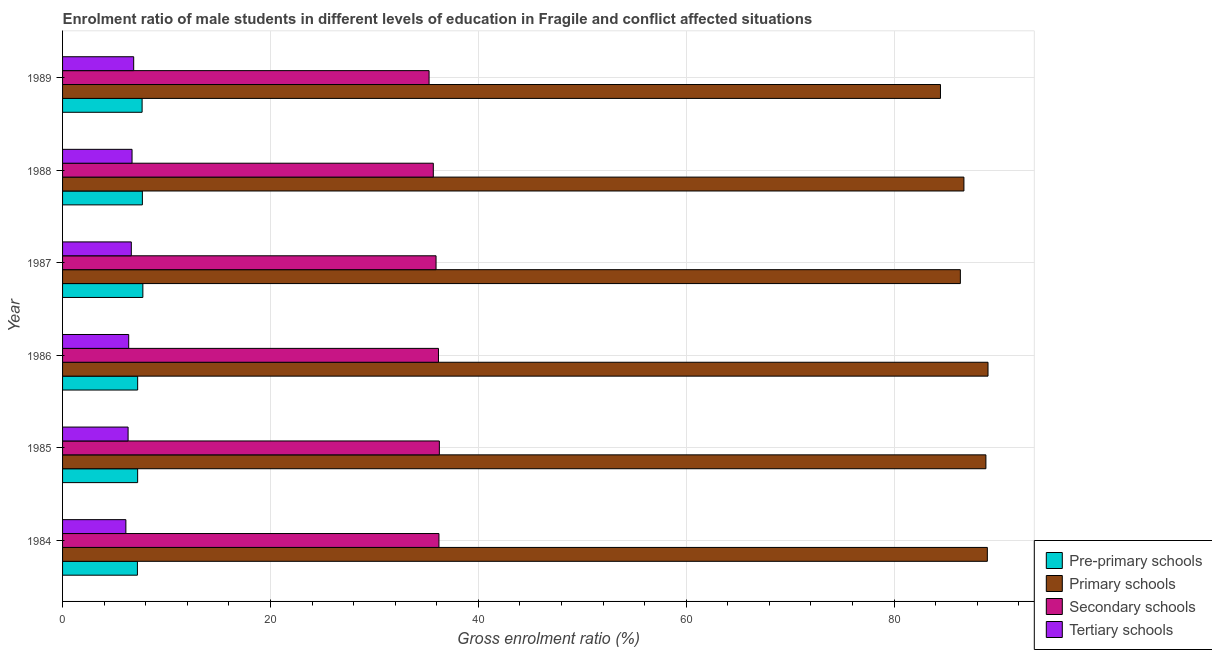How many groups of bars are there?
Offer a very short reply. 6. Are the number of bars on each tick of the Y-axis equal?
Your answer should be compact. Yes. How many bars are there on the 2nd tick from the top?
Ensure brevity in your answer.  4. What is the label of the 6th group of bars from the top?
Keep it short and to the point. 1984. What is the gross enrolment ratio(female) in tertiary schools in 1989?
Offer a terse response. 6.84. Across all years, what is the maximum gross enrolment ratio(female) in pre-primary schools?
Your response must be concise. 7.73. Across all years, what is the minimum gross enrolment ratio(female) in pre-primary schools?
Your answer should be compact. 7.2. In which year was the gross enrolment ratio(female) in tertiary schools maximum?
Offer a very short reply. 1989. What is the total gross enrolment ratio(female) in primary schools in the graph?
Make the answer very short. 524.46. What is the difference between the gross enrolment ratio(female) in tertiary schools in 1986 and that in 1988?
Your answer should be very brief. -0.32. What is the difference between the gross enrolment ratio(female) in tertiary schools in 1988 and the gross enrolment ratio(female) in secondary schools in 1987?
Give a very brief answer. -29.25. What is the average gross enrolment ratio(female) in pre-primary schools per year?
Provide a short and direct response. 7.45. In the year 1986, what is the difference between the gross enrolment ratio(female) in primary schools and gross enrolment ratio(female) in pre-primary schools?
Offer a very short reply. 81.82. In how many years, is the gross enrolment ratio(female) in tertiary schools greater than 88 %?
Offer a very short reply. 0. What is the difference between the highest and the second highest gross enrolment ratio(female) in secondary schools?
Your response must be concise. 0.04. What is the difference between the highest and the lowest gross enrolment ratio(female) in primary schools?
Your answer should be very brief. 4.57. In how many years, is the gross enrolment ratio(female) in tertiary schools greater than the average gross enrolment ratio(female) in tertiary schools taken over all years?
Provide a succinct answer. 3. What does the 2nd bar from the top in 1984 represents?
Keep it short and to the point. Secondary schools. What does the 3rd bar from the bottom in 1984 represents?
Your response must be concise. Secondary schools. How many bars are there?
Ensure brevity in your answer.  24. Are all the bars in the graph horizontal?
Keep it short and to the point. Yes. What is the difference between two consecutive major ticks on the X-axis?
Your answer should be very brief. 20. Does the graph contain grids?
Provide a succinct answer. Yes. How many legend labels are there?
Provide a short and direct response. 4. How are the legend labels stacked?
Keep it short and to the point. Vertical. What is the title of the graph?
Provide a succinct answer. Enrolment ratio of male students in different levels of education in Fragile and conflict affected situations. Does "Quality of logistic services" appear as one of the legend labels in the graph?
Provide a short and direct response. No. What is the label or title of the X-axis?
Provide a short and direct response. Gross enrolment ratio (%). What is the Gross enrolment ratio (%) of Pre-primary schools in 1984?
Your response must be concise. 7.2. What is the Gross enrolment ratio (%) of Primary schools in 1984?
Your response must be concise. 88.98. What is the Gross enrolment ratio (%) of Secondary schools in 1984?
Keep it short and to the point. 36.22. What is the Gross enrolment ratio (%) in Tertiary schools in 1984?
Give a very brief answer. 6.09. What is the Gross enrolment ratio (%) in Pre-primary schools in 1985?
Offer a terse response. 7.22. What is the Gross enrolment ratio (%) in Primary schools in 1985?
Your answer should be very brief. 88.84. What is the Gross enrolment ratio (%) of Secondary schools in 1985?
Offer a terse response. 36.26. What is the Gross enrolment ratio (%) of Tertiary schools in 1985?
Your answer should be very brief. 6.31. What is the Gross enrolment ratio (%) of Pre-primary schools in 1986?
Offer a very short reply. 7.23. What is the Gross enrolment ratio (%) of Primary schools in 1986?
Your answer should be compact. 89.05. What is the Gross enrolment ratio (%) in Secondary schools in 1986?
Your answer should be compact. 36.17. What is the Gross enrolment ratio (%) of Tertiary schools in 1986?
Make the answer very short. 6.36. What is the Gross enrolment ratio (%) in Pre-primary schools in 1987?
Provide a succinct answer. 7.73. What is the Gross enrolment ratio (%) of Primary schools in 1987?
Your answer should be compact. 86.39. What is the Gross enrolment ratio (%) in Secondary schools in 1987?
Keep it short and to the point. 35.94. What is the Gross enrolment ratio (%) in Tertiary schools in 1987?
Give a very brief answer. 6.61. What is the Gross enrolment ratio (%) in Pre-primary schools in 1988?
Provide a short and direct response. 7.68. What is the Gross enrolment ratio (%) in Primary schools in 1988?
Ensure brevity in your answer.  86.73. What is the Gross enrolment ratio (%) of Secondary schools in 1988?
Make the answer very short. 35.67. What is the Gross enrolment ratio (%) of Tertiary schools in 1988?
Your response must be concise. 6.69. What is the Gross enrolment ratio (%) in Pre-primary schools in 1989?
Ensure brevity in your answer.  7.65. What is the Gross enrolment ratio (%) in Primary schools in 1989?
Keep it short and to the point. 84.47. What is the Gross enrolment ratio (%) in Secondary schools in 1989?
Offer a very short reply. 35.27. What is the Gross enrolment ratio (%) of Tertiary schools in 1989?
Your response must be concise. 6.84. Across all years, what is the maximum Gross enrolment ratio (%) in Pre-primary schools?
Provide a short and direct response. 7.73. Across all years, what is the maximum Gross enrolment ratio (%) of Primary schools?
Give a very brief answer. 89.05. Across all years, what is the maximum Gross enrolment ratio (%) in Secondary schools?
Keep it short and to the point. 36.26. Across all years, what is the maximum Gross enrolment ratio (%) in Tertiary schools?
Your answer should be compact. 6.84. Across all years, what is the minimum Gross enrolment ratio (%) in Pre-primary schools?
Provide a succinct answer. 7.2. Across all years, what is the minimum Gross enrolment ratio (%) in Primary schools?
Give a very brief answer. 84.47. Across all years, what is the minimum Gross enrolment ratio (%) of Secondary schools?
Your answer should be compact. 35.27. Across all years, what is the minimum Gross enrolment ratio (%) in Tertiary schools?
Give a very brief answer. 6.09. What is the total Gross enrolment ratio (%) in Pre-primary schools in the graph?
Offer a very short reply. 44.71. What is the total Gross enrolment ratio (%) of Primary schools in the graph?
Ensure brevity in your answer.  524.46. What is the total Gross enrolment ratio (%) of Secondary schools in the graph?
Keep it short and to the point. 215.52. What is the total Gross enrolment ratio (%) in Tertiary schools in the graph?
Your response must be concise. 38.9. What is the difference between the Gross enrolment ratio (%) in Pre-primary schools in 1984 and that in 1985?
Keep it short and to the point. -0.02. What is the difference between the Gross enrolment ratio (%) in Primary schools in 1984 and that in 1985?
Keep it short and to the point. 0.14. What is the difference between the Gross enrolment ratio (%) of Secondary schools in 1984 and that in 1985?
Offer a very short reply. -0.04. What is the difference between the Gross enrolment ratio (%) of Tertiary schools in 1984 and that in 1985?
Provide a short and direct response. -0.21. What is the difference between the Gross enrolment ratio (%) of Pre-primary schools in 1984 and that in 1986?
Provide a short and direct response. -0.02. What is the difference between the Gross enrolment ratio (%) of Primary schools in 1984 and that in 1986?
Ensure brevity in your answer.  -0.06. What is the difference between the Gross enrolment ratio (%) in Secondary schools in 1984 and that in 1986?
Provide a succinct answer. 0.05. What is the difference between the Gross enrolment ratio (%) of Tertiary schools in 1984 and that in 1986?
Provide a short and direct response. -0.27. What is the difference between the Gross enrolment ratio (%) in Pre-primary schools in 1984 and that in 1987?
Give a very brief answer. -0.52. What is the difference between the Gross enrolment ratio (%) in Primary schools in 1984 and that in 1987?
Make the answer very short. 2.6. What is the difference between the Gross enrolment ratio (%) of Secondary schools in 1984 and that in 1987?
Provide a short and direct response. 0.28. What is the difference between the Gross enrolment ratio (%) in Tertiary schools in 1984 and that in 1987?
Your answer should be very brief. -0.52. What is the difference between the Gross enrolment ratio (%) of Pre-primary schools in 1984 and that in 1988?
Give a very brief answer. -0.48. What is the difference between the Gross enrolment ratio (%) of Primary schools in 1984 and that in 1988?
Keep it short and to the point. 2.25. What is the difference between the Gross enrolment ratio (%) of Secondary schools in 1984 and that in 1988?
Offer a very short reply. 0.54. What is the difference between the Gross enrolment ratio (%) of Tertiary schools in 1984 and that in 1988?
Provide a succinct answer. -0.59. What is the difference between the Gross enrolment ratio (%) of Pre-primary schools in 1984 and that in 1989?
Your answer should be compact. -0.45. What is the difference between the Gross enrolment ratio (%) of Primary schools in 1984 and that in 1989?
Your response must be concise. 4.51. What is the difference between the Gross enrolment ratio (%) in Secondary schools in 1984 and that in 1989?
Your answer should be compact. 0.95. What is the difference between the Gross enrolment ratio (%) of Tertiary schools in 1984 and that in 1989?
Ensure brevity in your answer.  -0.75. What is the difference between the Gross enrolment ratio (%) in Pre-primary schools in 1985 and that in 1986?
Your response must be concise. -0. What is the difference between the Gross enrolment ratio (%) in Primary schools in 1985 and that in 1986?
Your answer should be very brief. -0.2. What is the difference between the Gross enrolment ratio (%) of Secondary schools in 1985 and that in 1986?
Ensure brevity in your answer.  0.09. What is the difference between the Gross enrolment ratio (%) of Tertiary schools in 1985 and that in 1986?
Offer a very short reply. -0.06. What is the difference between the Gross enrolment ratio (%) of Pre-primary schools in 1985 and that in 1987?
Ensure brevity in your answer.  -0.5. What is the difference between the Gross enrolment ratio (%) in Primary schools in 1985 and that in 1987?
Offer a terse response. 2.46. What is the difference between the Gross enrolment ratio (%) of Secondary schools in 1985 and that in 1987?
Ensure brevity in your answer.  0.32. What is the difference between the Gross enrolment ratio (%) in Tertiary schools in 1985 and that in 1987?
Provide a succinct answer. -0.31. What is the difference between the Gross enrolment ratio (%) in Pre-primary schools in 1985 and that in 1988?
Your response must be concise. -0.46. What is the difference between the Gross enrolment ratio (%) in Primary schools in 1985 and that in 1988?
Make the answer very short. 2.12. What is the difference between the Gross enrolment ratio (%) of Secondary schools in 1985 and that in 1988?
Ensure brevity in your answer.  0.58. What is the difference between the Gross enrolment ratio (%) of Tertiary schools in 1985 and that in 1988?
Make the answer very short. -0.38. What is the difference between the Gross enrolment ratio (%) in Pre-primary schools in 1985 and that in 1989?
Your response must be concise. -0.43. What is the difference between the Gross enrolment ratio (%) of Primary schools in 1985 and that in 1989?
Ensure brevity in your answer.  4.37. What is the difference between the Gross enrolment ratio (%) of Tertiary schools in 1985 and that in 1989?
Provide a succinct answer. -0.54. What is the difference between the Gross enrolment ratio (%) of Pre-primary schools in 1986 and that in 1987?
Make the answer very short. -0.5. What is the difference between the Gross enrolment ratio (%) in Primary schools in 1986 and that in 1987?
Your answer should be compact. 2.66. What is the difference between the Gross enrolment ratio (%) in Secondary schools in 1986 and that in 1987?
Ensure brevity in your answer.  0.23. What is the difference between the Gross enrolment ratio (%) in Tertiary schools in 1986 and that in 1987?
Keep it short and to the point. -0.25. What is the difference between the Gross enrolment ratio (%) of Pre-primary schools in 1986 and that in 1988?
Give a very brief answer. -0.45. What is the difference between the Gross enrolment ratio (%) in Primary schools in 1986 and that in 1988?
Offer a terse response. 2.32. What is the difference between the Gross enrolment ratio (%) of Secondary schools in 1986 and that in 1988?
Your answer should be very brief. 0.5. What is the difference between the Gross enrolment ratio (%) of Tertiary schools in 1986 and that in 1988?
Keep it short and to the point. -0.32. What is the difference between the Gross enrolment ratio (%) in Pre-primary schools in 1986 and that in 1989?
Your answer should be compact. -0.43. What is the difference between the Gross enrolment ratio (%) in Primary schools in 1986 and that in 1989?
Your answer should be compact. 4.57. What is the difference between the Gross enrolment ratio (%) of Secondary schools in 1986 and that in 1989?
Provide a short and direct response. 0.9. What is the difference between the Gross enrolment ratio (%) in Tertiary schools in 1986 and that in 1989?
Your answer should be very brief. -0.48. What is the difference between the Gross enrolment ratio (%) in Pre-primary schools in 1987 and that in 1988?
Provide a succinct answer. 0.05. What is the difference between the Gross enrolment ratio (%) in Primary schools in 1987 and that in 1988?
Keep it short and to the point. -0.34. What is the difference between the Gross enrolment ratio (%) of Secondary schools in 1987 and that in 1988?
Give a very brief answer. 0.26. What is the difference between the Gross enrolment ratio (%) in Tertiary schools in 1987 and that in 1988?
Offer a very short reply. -0.07. What is the difference between the Gross enrolment ratio (%) of Pre-primary schools in 1987 and that in 1989?
Your answer should be very brief. 0.07. What is the difference between the Gross enrolment ratio (%) in Primary schools in 1987 and that in 1989?
Your answer should be very brief. 1.91. What is the difference between the Gross enrolment ratio (%) of Secondary schools in 1987 and that in 1989?
Give a very brief answer. 0.67. What is the difference between the Gross enrolment ratio (%) of Tertiary schools in 1987 and that in 1989?
Give a very brief answer. -0.23. What is the difference between the Gross enrolment ratio (%) of Pre-primary schools in 1988 and that in 1989?
Offer a very short reply. 0.03. What is the difference between the Gross enrolment ratio (%) of Primary schools in 1988 and that in 1989?
Provide a succinct answer. 2.26. What is the difference between the Gross enrolment ratio (%) in Secondary schools in 1988 and that in 1989?
Provide a short and direct response. 0.41. What is the difference between the Gross enrolment ratio (%) in Tertiary schools in 1988 and that in 1989?
Give a very brief answer. -0.16. What is the difference between the Gross enrolment ratio (%) of Pre-primary schools in 1984 and the Gross enrolment ratio (%) of Primary schools in 1985?
Your answer should be very brief. -81.64. What is the difference between the Gross enrolment ratio (%) in Pre-primary schools in 1984 and the Gross enrolment ratio (%) in Secondary schools in 1985?
Provide a succinct answer. -29.05. What is the difference between the Gross enrolment ratio (%) in Pre-primary schools in 1984 and the Gross enrolment ratio (%) in Tertiary schools in 1985?
Ensure brevity in your answer.  0.9. What is the difference between the Gross enrolment ratio (%) of Primary schools in 1984 and the Gross enrolment ratio (%) of Secondary schools in 1985?
Your answer should be compact. 52.73. What is the difference between the Gross enrolment ratio (%) in Primary schools in 1984 and the Gross enrolment ratio (%) in Tertiary schools in 1985?
Your answer should be very brief. 82.68. What is the difference between the Gross enrolment ratio (%) of Secondary schools in 1984 and the Gross enrolment ratio (%) of Tertiary schools in 1985?
Give a very brief answer. 29.91. What is the difference between the Gross enrolment ratio (%) of Pre-primary schools in 1984 and the Gross enrolment ratio (%) of Primary schools in 1986?
Provide a short and direct response. -81.84. What is the difference between the Gross enrolment ratio (%) in Pre-primary schools in 1984 and the Gross enrolment ratio (%) in Secondary schools in 1986?
Your answer should be compact. -28.97. What is the difference between the Gross enrolment ratio (%) of Pre-primary schools in 1984 and the Gross enrolment ratio (%) of Tertiary schools in 1986?
Your response must be concise. 0.84. What is the difference between the Gross enrolment ratio (%) of Primary schools in 1984 and the Gross enrolment ratio (%) of Secondary schools in 1986?
Provide a succinct answer. 52.81. What is the difference between the Gross enrolment ratio (%) in Primary schools in 1984 and the Gross enrolment ratio (%) in Tertiary schools in 1986?
Give a very brief answer. 82.62. What is the difference between the Gross enrolment ratio (%) of Secondary schools in 1984 and the Gross enrolment ratio (%) of Tertiary schools in 1986?
Your answer should be compact. 29.85. What is the difference between the Gross enrolment ratio (%) in Pre-primary schools in 1984 and the Gross enrolment ratio (%) in Primary schools in 1987?
Your response must be concise. -79.18. What is the difference between the Gross enrolment ratio (%) in Pre-primary schools in 1984 and the Gross enrolment ratio (%) in Secondary schools in 1987?
Keep it short and to the point. -28.73. What is the difference between the Gross enrolment ratio (%) of Pre-primary schools in 1984 and the Gross enrolment ratio (%) of Tertiary schools in 1987?
Give a very brief answer. 0.59. What is the difference between the Gross enrolment ratio (%) of Primary schools in 1984 and the Gross enrolment ratio (%) of Secondary schools in 1987?
Ensure brevity in your answer.  53.05. What is the difference between the Gross enrolment ratio (%) of Primary schools in 1984 and the Gross enrolment ratio (%) of Tertiary schools in 1987?
Your response must be concise. 82.37. What is the difference between the Gross enrolment ratio (%) of Secondary schools in 1984 and the Gross enrolment ratio (%) of Tertiary schools in 1987?
Make the answer very short. 29.6. What is the difference between the Gross enrolment ratio (%) of Pre-primary schools in 1984 and the Gross enrolment ratio (%) of Primary schools in 1988?
Provide a short and direct response. -79.53. What is the difference between the Gross enrolment ratio (%) in Pre-primary schools in 1984 and the Gross enrolment ratio (%) in Secondary schools in 1988?
Provide a succinct answer. -28.47. What is the difference between the Gross enrolment ratio (%) in Pre-primary schools in 1984 and the Gross enrolment ratio (%) in Tertiary schools in 1988?
Provide a short and direct response. 0.52. What is the difference between the Gross enrolment ratio (%) in Primary schools in 1984 and the Gross enrolment ratio (%) in Secondary schools in 1988?
Keep it short and to the point. 53.31. What is the difference between the Gross enrolment ratio (%) of Primary schools in 1984 and the Gross enrolment ratio (%) of Tertiary schools in 1988?
Your answer should be compact. 82.3. What is the difference between the Gross enrolment ratio (%) in Secondary schools in 1984 and the Gross enrolment ratio (%) in Tertiary schools in 1988?
Provide a succinct answer. 29.53. What is the difference between the Gross enrolment ratio (%) in Pre-primary schools in 1984 and the Gross enrolment ratio (%) in Primary schools in 1989?
Your response must be concise. -77.27. What is the difference between the Gross enrolment ratio (%) in Pre-primary schools in 1984 and the Gross enrolment ratio (%) in Secondary schools in 1989?
Keep it short and to the point. -28.06. What is the difference between the Gross enrolment ratio (%) in Pre-primary schools in 1984 and the Gross enrolment ratio (%) in Tertiary schools in 1989?
Your answer should be compact. 0.36. What is the difference between the Gross enrolment ratio (%) of Primary schools in 1984 and the Gross enrolment ratio (%) of Secondary schools in 1989?
Make the answer very short. 53.72. What is the difference between the Gross enrolment ratio (%) of Primary schools in 1984 and the Gross enrolment ratio (%) of Tertiary schools in 1989?
Your answer should be very brief. 82.14. What is the difference between the Gross enrolment ratio (%) in Secondary schools in 1984 and the Gross enrolment ratio (%) in Tertiary schools in 1989?
Your answer should be compact. 29.37. What is the difference between the Gross enrolment ratio (%) of Pre-primary schools in 1985 and the Gross enrolment ratio (%) of Primary schools in 1986?
Give a very brief answer. -81.82. What is the difference between the Gross enrolment ratio (%) in Pre-primary schools in 1985 and the Gross enrolment ratio (%) in Secondary schools in 1986?
Ensure brevity in your answer.  -28.95. What is the difference between the Gross enrolment ratio (%) of Pre-primary schools in 1985 and the Gross enrolment ratio (%) of Tertiary schools in 1986?
Your response must be concise. 0.86. What is the difference between the Gross enrolment ratio (%) of Primary schools in 1985 and the Gross enrolment ratio (%) of Secondary schools in 1986?
Your response must be concise. 52.67. What is the difference between the Gross enrolment ratio (%) of Primary schools in 1985 and the Gross enrolment ratio (%) of Tertiary schools in 1986?
Provide a short and direct response. 82.48. What is the difference between the Gross enrolment ratio (%) of Secondary schools in 1985 and the Gross enrolment ratio (%) of Tertiary schools in 1986?
Make the answer very short. 29.89. What is the difference between the Gross enrolment ratio (%) in Pre-primary schools in 1985 and the Gross enrolment ratio (%) in Primary schools in 1987?
Provide a succinct answer. -79.16. What is the difference between the Gross enrolment ratio (%) in Pre-primary schools in 1985 and the Gross enrolment ratio (%) in Secondary schools in 1987?
Give a very brief answer. -28.71. What is the difference between the Gross enrolment ratio (%) in Pre-primary schools in 1985 and the Gross enrolment ratio (%) in Tertiary schools in 1987?
Keep it short and to the point. 0.61. What is the difference between the Gross enrolment ratio (%) of Primary schools in 1985 and the Gross enrolment ratio (%) of Secondary schools in 1987?
Offer a very short reply. 52.91. What is the difference between the Gross enrolment ratio (%) in Primary schools in 1985 and the Gross enrolment ratio (%) in Tertiary schools in 1987?
Make the answer very short. 82.23. What is the difference between the Gross enrolment ratio (%) in Secondary schools in 1985 and the Gross enrolment ratio (%) in Tertiary schools in 1987?
Provide a succinct answer. 29.64. What is the difference between the Gross enrolment ratio (%) of Pre-primary schools in 1985 and the Gross enrolment ratio (%) of Primary schools in 1988?
Offer a very short reply. -79.5. What is the difference between the Gross enrolment ratio (%) of Pre-primary schools in 1985 and the Gross enrolment ratio (%) of Secondary schools in 1988?
Your answer should be very brief. -28.45. What is the difference between the Gross enrolment ratio (%) of Pre-primary schools in 1985 and the Gross enrolment ratio (%) of Tertiary schools in 1988?
Provide a short and direct response. 0.54. What is the difference between the Gross enrolment ratio (%) in Primary schools in 1985 and the Gross enrolment ratio (%) in Secondary schools in 1988?
Your answer should be very brief. 53.17. What is the difference between the Gross enrolment ratio (%) in Primary schools in 1985 and the Gross enrolment ratio (%) in Tertiary schools in 1988?
Ensure brevity in your answer.  82.16. What is the difference between the Gross enrolment ratio (%) in Secondary schools in 1985 and the Gross enrolment ratio (%) in Tertiary schools in 1988?
Your response must be concise. 29.57. What is the difference between the Gross enrolment ratio (%) of Pre-primary schools in 1985 and the Gross enrolment ratio (%) of Primary schools in 1989?
Offer a very short reply. -77.25. What is the difference between the Gross enrolment ratio (%) of Pre-primary schools in 1985 and the Gross enrolment ratio (%) of Secondary schools in 1989?
Offer a terse response. -28.04. What is the difference between the Gross enrolment ratio (%) of Pre-primary schools in 1985 and the Gross enrolment ratio (%) of Tertiary schools in 1989?
Offer a terse response. 0.38. What is the difference between the Gross enrolment ratio (%) of Primary schools in 1985 and the Gross enrolment ratio (%) of Secondary schools in 1989?
Your answer should be compact. 53.58. What is the difference between the Gross enrolment ratio (%) of Primary schools in 1985 and the Gross enrolment ratio (%) of Tertiary schools in 1989?
Provide a succinct answer. 82. What is the difference between the Gross enrolment ratio (%) in Secondary schools in 1985 and the Gross enrolment ratio (%) in Tertiary schools in 1989?
Provide a succinct answer. 29.41. What is the difference between the Gross enrolment ratio (%) in Pre-primary schools in 1986 and the Gross enrolment ratio (%) in Primary schools in 1987?
Offer a very short reply. -79.16. What is the difference between the Gross enrolment ratio (%) of Pre-primary schools in 1986 and the Gross enrolment ratio (%) of Secondary schools in 1987?
Make the answer very short. -28.71. What is the difference between the Gross enrolment ratio (%) in Pre-primary schools in 1986 and the Gross enrolment ratio (%) in Tertiary schools in 1987?
Offer a very short reply. 0.61. What is the difference between the Gross enrolment ratio (%) in Primary schools in 1986 and the Gross enrolment ratio (%) in Secondary schools in 1987?
Offer a terse response. 53.11. What is the difference between the Gross enrolment ratio (%) of Primary schools in 1986 and the Gross enrolment ratio (%) of Tertiary schools in 1987?
Offer a terse response. 82.43. What is the difference between the Gross enrolment ratio (%) in Secondary schools in 1986 and the Gross enrolment ratio (%) in Tertiary schools in 1987?
Offer a very short reply. 29.55. What is the difference between the Gross enrolment ratio (%) in Pre-primary schools in 1986 and the Gross enrolment ratio (%) in Primary schools in 1988?
Provide a succinct answer. -79.5. What is the difference between the Gross enrolment ratio (%) in Pre-primary schools in 1986 and the Gross enrolment ratio (%) in Secondary schools in 1988?
Give a very brief answer. -28.45. What is the difference between the Gross enrolment ratio (%) in Pre-primary schools in 1986 and the Gross enrolment ratio (%) in Tertiary schools in 1988?
Your response must be concise. 0.54. What is the difference between the Gross enrolment ratio (%) in Primary schools in 1986 and the Gross enrolment ratio (%) in Secondary schools in 1988?
Ensure brevity in your answer.  53.37. What is the difference between the Gross enrolment ratio (%) in Primary schools in 1986 and the Gross enrolment ratio (%) in Tertiary schools in 1988?
Ensure brevity in your answer.  82.36. What is the difference between the Gross enrolment ratio (%) in Secondary schools in 1986 and the Gross enrolment ratio (%) in Tertiary schools in 1988?
Offer a terse response. 29.48. What is the difference between the Gross enrolment ratio (%) of Pre-primary schools in 1986 and the Gross enrolment ratio (%) of Primary schools in 1989?
Ensure brevity in your answer.  -77.25. What is the difference between the Gross enrolment ratio (%) in Pre-primary schools in 1986 and the Gross enrolment ratio (%) in Secondary schools in 1989?
Your answer should be compact. -28.04. What is the difference between the Gross enrolment ratio (%) in Pre-primary schools in 1986 and the Gross enrolment ratio (%) in Tertiary schools in 1989?
Your response must be concise. 0.38. What is the difference between the Gross enrolment ratio (%) in Primary schools in 1986 and the Gross enrolment ratio (%) in Secondary schools in 1989?
Your answer should be compact. 53.78. What is the difference between the Gross enrolment ratio (%) of Primary schools in 1986 and the Gross enrolment ratio (%) of Tertiary schools in 1989?
Your answer should be very brief. 82.2. What is the difference between the Gross enrolment ratio (%) of Secondary schools in 1986 and the Gross enrolment ratio (%) of Tertiary schools in 1989?
Your answer should be compact. 29.33. What is the difference between the Gross enrolment ratio (%) in Pre-primary schools in 1987 and the Gross enrolment ratio (%) in Primary schools in 1988?
Your answer should be very brief. -79. What is the difference between the Gross enrolment ratio (%) in Pre-primary schools in 1987 and the Gross enrolment ratio (%) in Secondary schools in 1988?
Provide a succinct answer. -27.95. What is the difference between the Gross enrolment ratio (%) of Pre-primary schools in 1987 and the Gross enrolment ratio (%) of Tertiary schools in 1988?
Provide a succinct answer. 1.04. What is the difference between the Gross enrolment ratio (%) in Primary schools in 1987 and the Gross enrolment ratio (%) in Secondary schools in 1988?
Provide a short and direct response. 50.71. What is the difference between the Gross enrolment ratio (%) in Primary schools in 1987 and the Gross enrolment ratio (%) in Tertiary schools in 1988?
Provide a short and direct response. 79.7. What is the difference between the Gross enrolment ratio (%) of Secondary schools in 1987 and the Gross enrolment ratio (%) of Tertiary schools in 1988?
Provide a succinct answer. 29.25. What is the difference between the Gross enrolment ratio (%) of Pre-primary schools in 1987 and the Gross enrolment ratio (%) of Primary schools in 1989?
Keep it short and to the point. -76.75. What is the difference between the Gross enrolment ratio (%) in Pre-primary schools in 1987 and the Gross enrolment ratio (%) in Secondary schools in 1989?
Ensure brevity in your answer.  -27.54. What is the difference between the Gross enrolment ratio (%) in Pre-primary schools in 1987 and the Gross enrolment ratio (%) in Tertiary schools in 1989?
Offer a very short reply. 0.88. What is the difference between the Gross enrolment ratio (%) of Primary schools in 1987 and the Gross enrolment ratio (%) of Secondary schools in 1989?
Make the answer very short. 51.12. What is the difference between the Gross enrolment ratio (%) of Primary schools in 1987 and the Gross enrolment ratio (%) of Tertiary schools in 1989?
Provide a succinct answer. 79.54. What is the difference between the Gross enrolment ratio (%) in Secondary schools in 1987 and the Gross enrolment ratio (%) in Tertiary schools in 1989?
Your answer should be very brief. 29.09. What is the difference between the Gross enrolment ratio (%) in Pre-primary schools in 1988 and the Gross enrolment ratio (%) in Primary schools in 1989?
Your answer should be compact. -76.79. What is the difference between the Gross enrolment ratio (%) in Pre-primary schools in 1988 and the Gross enrolment ratio (%) in Secondary schools in 1989?
Offer a very short reply. -27.59. What is the difference between the Gross enrolment ratio (%) of Pre-primary schools in 1988 and the Gross enrolment ratio (%) of Tertiary schools in 1989?
Give a very brief answer. 0.84. What is the difference between the Gross enrolment ratio (%) of Primary schools in 1988 and the Gross enrolment ratio (%) of Secondary schools in 1989?
Provide a succinct answer. 51.46. What is the difference between the Gross enrolment ratio (%) in Primary schools in 1988 and the Gross enrolment ratio (%) in Tertiary schools in 1989?
Your response must be concise. 79.88. What is the difference between the Gross enrolment ratio (%) in Secondary schools in 1988 and the Gross enrolment ratio (%) in Tertiary schools in 1989?
Your answer should be very brief. 28.83. What is the average Gross enrolment ratio (%) in Pre-primary schools per year?
Your response must be concise. 7.45. What is the average Gross enrolment ratio (%) of Primary schools per year?
Offer a very short reply. 87.41. What is the average Gross enrolment ratio (%) of Secondary schools per year?
Provide a succinct answer. 35.92. What is the average Gross enrolment ratio (%) of Tertiary schools per year?
Provide a succinct answer. 6.48. In the year 1984, what is the difference between the Gross enrolment ratio (%) of Pre-primary schools and Gross enrolment ratio (%) of Primary schools?
Your answer should be compact. -81.78. In the year 1984, what is the difference between the Gross enrolment ratio (%) in Pre-primary schools and Gross enrolment ratio (%) in Secondary schools?
Give a very brief answer. -29.01. In the year 1984, what is the difference between the Gross enrolment ratio (%) in Pre-primary schools and Gross enrolment ratio (%) in Tertiary schools?
Your answer should be very brief. 1.11. In the year 1984, what is the difference between the Gross enrolment ratio (%) of Primary schools and Gross enrolment ratio (%) of Secondary schools?
Keep it short and to the point. 52.77. In the year 1984, what is the difference between the Gross enrolment ratio (%) of Primary schools and Gross enrolment ratio (%) of Tertiary schools?
Your answer should be very brief. 82.89. In the year 1984, what is the difference between the Gross enrolment ratio (%) in Secondary schools and Gross enrolment ratio (%) in Tertiary schools?
Provide a succinct answer. 30.12. In the year 1985, what is the difference between the Gross enrolment ratio (%) of Pre-primary schools and Gross enrolment ratio (%) of Primary schools?
Your response must be concise. -81.62. In the year 1985, what is the difference between the Gross enrolment ratio (%) in Pre-primary schools and Gross enrolment ratio (%) in Secondary schools?
Make the answer very short. -29.03. In the year 1985, what is the difference between the Gross enrolment ratio (%) of Pre-primary schools and Gross enrolment ratio (%) of Tertiary schools?
Your answer should be compact. 0.92. In the year 1985, what is the difference between the Gross enrolment ratio (%) in Primary schools and Gross enrolment ratio (%) in Secondary schools?
Ensure brevity in your answer.  52.59. In the year 1985, what is the difference between the Gross enrolment ratio (%) of Primary schools and Gross enrolment ratio (%) of Tertiary schools?
Your answer should be very brief. 82.54. In the year 1985, what is the difference between the Gross enrolment ratio (%) of Secondary schools and Gross enrolment ratio (%) of Tertiary schools?
Make the answer very short. 29.95. In the year 1986, what is the difference between the Gross enrolment ratio (%) of Pre-primary schools and Gross enrolment ratio (%) of Primary schools?
Offer a very short reply. -81.82. In the year 1986, what is the difference between the Gross enrolment ratio (%) in Pre-primary schools and Gross enrolment ratio (%) in Secondary schools?
Your response must be concise. -28.94. In the year 1986, what is the difference between the Gross enrolment ratio (%) of Pre-primary schools and Gross enrolment ratio (%) of Tertiary schools?
Provide a succinct answer. 0.86. In the year 1986, what is the difference between the Gross enrolment ratio (%) of Primary schools and Gross enrolment ratio (%) of Secondary schools?
Provide a short and direct response. 52.88. In the year 1986, what is the difference between the Gross enrolment ratio (%) in Primary schools and Gross enrolment ratio (%) in Tertiary schools?
Ensure brevity in your answer.  82.68. In the year 1986, what is the difference between the Gross enrolment ratio (%) of Secondary schools and Gross enrolment ratio (%) of Tertiary schools?
Your answer should be compact. 29.8. In the year 1987, what is the difference between the Gross enrolment ratio (%) of Pre-primary schools and Gross enrolment ratio (%) of Primary schools?
Ensure brevity in your answer.  -78.66. In the year 1987, what is the difference between the Gross enrolment ratio (%) in Pre-primary schools and Gross enrolment ratio (%) in Secondary schools?
Your response must be concise. -28.21. In the year 1987, what is the difference between the Gross enrolment ratio (%) of Pre-primary schools and Gross enrolment ratio (%) of Tertiary schools?
Give a very brief answer. 1.11. In the year 1987, what is the difference between the Gross enrolment ratio (%) of Primary schools and Gross enrolment ratio (%) of Secondary schools?
Your answer should be compact. 50.45. In the year 1987, what is the difference between the Gross enrolment ratio (%) of Primary schools and Gross enrolment ratio (%) of Tertiary schools?
Provide a short and direct response. 79.77. In the year 1987, what is the difference between the Gross enrolment ratio (%) in Secondary schools and Gross enrolment ratio (%) in Tertiary schools?
Give a very brief answer. 29.32. In the year 1988, what is the difference between the Gross enrolment ratio (%) of Pre-primary schools and Gross enrolment ratio (%) of Primary schools?
Make the answer very short. -79.05. In the year 1988, what is the difference between the Gross enrolment ratio (%) of Pre-primary schools and Gross enrolment ratio (%) of Secondary schools?
Give a very brief answer. -27.99. In the year 1988, what is the difference between the Gross enrolment ratio (%) of Primary schools and Gross enrolment ratio (%) of Secondary schools?
Your answer should be very brief. 51.06. In the year 1988, what is the difference between the Gross enrolment ratio (%) of Primary schools and Gross enrolment ratio (%) of Tertiary schools?
Provide a succinct answer. 80.04. In the year 1988, what is the difference between the Gross enrolment ratio (%) of Secondary schools and Gross enrolment ratio (%) of Tertiary schools?
Your response must be concise. 28.99. In the year 1989, what is the difference between the Gross enrolment ratio (%) of Pre-primary schools and Gross enrolment ratio (%) of Primary schools?
Keep it short and to the point. -76.82. In the year 1989, what is the difference between the Gross enrolment ratio (%) of Pre-primary schools and Gross enrolment ratio (%) of Secondary schools?
Offer a very short reply. -27.61. In the year 1989, what is the difference between the Gross enrolment ratio (%) in Pre-primary schools and Gross enrolment ratio (%) in Tertiary schools?
Your answer should be compact. 0.81. In the year 1989, what is the difference between the Gross enrolment ratio (%) in Primary schools and Gross enrolment ratio (%) in Secondary schools?
Your response must be concise. 49.21. In the year 1989, what is the difference between the Gross enrolment ratio (%) in Primary schools and Gross enrolment ratio (%) in Tertiary schools?
Make the answer very short. 77.63. In the year 1989, what is the difference between the Gross enrolment ratio (%) of Secondary schools and Gross enrolment ratio (%) of Tertiary schools?
Provide a short and direct response. 28.42. What is the ratio of the Gross enrolment ratio (%) of Pre-primary schools in 1984 to that in 1985?
Make the answer very short. 1. What is the ratio of the Gross enrolment ratio (%) of Secondary schools in 1984 to that in 1985?
Your answer should be very brief. 1. What is the ratio of the Gross enrolment ratio (%) of Tertiary schools in 1984 to that in 1985?
Keep it short and to the point. 0.97. What is the ratio of the Gross enrolment ratio (%) of Pre-primary schools in 1984 to that in 1986?
Make the answer very short. 1. What is the ratio of the Gross enrolment ratio (%) in Primary schools in 1984 to that in 1986?
Your answer should be compact. 1. What is the ratio of the Gross enrolment ratio (%) of Tertiary schools in 1984 to that in 1986?
Give a very brief answer. 0.96. What is the ratio of the Gross enrolment ratio (%) of Pre-primary schools in 1984 to that in 1987?
Provide a short and direct response. 0.93. What is the ratio of the Gross enrolment ratio (%) in Primary schools in 1984 to that in 1987?
Offer a very short reply. 1.03. What is the ratio of the Gross enrolment ratio (%) of Tertiary schools in 1984 to that in 1987?
Your response must be concise. 0.92. What is the ratio of the Gross enrolment ratio (%) in Pre-primary schools in 1984 to that in 1988?
Keep it short and to the point. 0.94. What is the ratio of the Gross enrolment ratio (%) in Secondary schools in 1984 to that in 1988?
Give a very brief answer. 1.02. What is the ratio of the Gross enrolment ratio (%) in Tertiary schools in 1984 to that in 1988?
Keep it short and to the point. 0.91. What is the ratio of the Gross enrolment ratio (%) in Pre-primary schools in 1984 to that in 1989?
Offer a very short reply. 0.94. What is the ratio of the Gross enrolment ratio (%) of Primary schools in 1984 to that in 1989?
Your answer should be very brief. 1.05. What is the ratio of the Gross enrolment ratio (%) in Secondary schools in 1984 to that in 1989?
Provide a succinct answer. 1.03. What is the ratio of the Gross enrolment ratio (%) of Tertiary schools in 1984 to that in 1989?
Your response must be concise. 0.89. What is the ratio of the Gross enrolment ratio (%) in Primary schools in 1985 to that in 1986?
Your answer should be very brief. 1. What is the ratio of the Gross enrolment ratio (%) in Secondary schools in 1985 to that in 1986?
Your answer should be compact. 1. What is the ratio of the Gross enrolment ratio (%) of Pre-primary schools in 1985 to that in 1987?
Provide a short and direct response. 0.94. What is the ratio of the Gross enrolment ratio (%) of Primary schools in 1985 to that in 1987?
Offer a terse response. 1.03. What is the ratio of the Gross enrolment ratio (%) of Secondary schools in 1985 to that in 1987?
Offer a very short reply. 1.01. What is the ratio of the Gross enrolment ratio (%) of Tertiary schools in 1985 to that in 1987?
Ensure brevity in your answer.  0.95. What is the ratio of the Gross enrolment ratio (%) of Pre-primary schools in 1985 to that in 1988?
Offer a terse response. 0.94. What is the ratio of the Gross enrolment ratio (%) in Primary schools in 1985 to that in 1988?
Your answer should be compact. 1.02. What is the ratio of the Gross enrolment ratio (%) of Secondary schools in 1985 to that in 1988?
Ensure brevity in your answer.  1.02. What is the ratio of the Gross enrolment ratio (%) of Tertiary schools in 1985 to that in 1988?
Provide a succinct answer. 0.94. What is the ratio of the Gross enrolment ratio (%) in Pre-primary schools in 1985 to that in 1989?
Offer a terse response. 0.94. What is the ratio of the Gross enrolment ratio (%) of Primary schools in 1985 to that in 1989?
Your response must be concise. 1.05. What is the ratio of the Gross enrolment ratio (%) of Secondary schools in 1985 to that in 1989?
Keep it short and to the point. 1.03. What is the ratio of the Gross enrolment ratio (%) in Tertiary schools in 1985 to that in 1989?
Make the answer very short. 0.92. What is the ratio of the Gross enrolment ratio (%) of Pre-primary schools in 1986 to that in 1987?
Ensure brevity in your answer.  0.94. What is the ratio of the Gross enrolment ratio (%) in Primary schools in 1986 to that in 1987?
Provide a succinct answer. 1.03. What is the ratio of the Gross enrolment ratio (%) of Tertiary schools in 1986 to that in 1987?
Ensure brevity in your answer.  0.96. What is the ratio of the Gross enrolment ratio (%) in Pre-primary schools in 1986 to that in 1988?
Your answer should be very brief. 0.94. What is the ratio of the Gross enrolment ratio (%) of Primary schools in 1986 to that in 1988?
Your answer should be compact. 1.03. What is the ratio of the Gross enrolment ratio (%) in Secondary schools in 1986 to that in 1988?
Your response must be concise. 1.01. What is the ratio of the Gross enrolment ratio (%) of Pre-primary schools in 1986 to that in 1989?
Give a very brief answer. 0.94. What is the ratio of the Gross enrolment ratio (%) in Primary schools in 1986 to that in 1989?
Offer a very short reply. 1.05. What is the ratio of the Gross enrolment ratio (%) in Secondary schools in 1986 to that in 1989?
Offer a very short reply. 1.03. What is the ratio of the Gross enrolment ratio (%) of Tertiary schools in 1986 to that in 1989?
Give a very brief answer. 0.93. What is the ratio of the Gross enrolment ratio (%) of Primary schools in 1987 to that in 1988?
Make the answer very short. 1. What is the ratio of the Gross enrolment ratio (%) in Secondary schools in 1987 to that in 1988?
Offer a terse response. 1.01. What is the ratio of the Gross enrolment ratio (%) in Tertiary schools in 1987 to that in 1988?
Keep it short and to the point. 0.99. What is the ratio of the Gross enrolment ratio (%) of Pre-primary schools in 1987 to that in 1989?
Offer a terse response. 1.01. What is the ratio of the Gross enrolment ratio (%) of Primary schools in 1987 to that in 1989?
Give a very brief answer. 1.02. What is the ratio of the Gross enrolment ratio (%) in Tertiary schools in 1987 to that in 1989?
Offer a terse response. 0.97. What is the ratio of the Gross enrolment ratio (%) of Primary schools in 1988 to that in 1989?
Make the answer very short. 1.03. What is the ratio of the Gross enrolment ratio (%) of Secondary schools in 1988 to that in 1989?
Provide a succinct answer. 1.01. What is the ratio of the Gross enrolment ratio (%) of Tertiary schools in 1988 to that in 1989?
Provide a short and direct response. 0.98. What is the difference between the highest and the second highest Gross enrolment ratio (%) of Pre-primary schools?
Make the answer very short. 0.05. What is the difference between the highest and the second highest Gross enrolment ratio (%) in Primary schools?
Offer a terse response. 0.06. What is the difference between the highest and the second highest Gross enrolment ratio (%) of Secondary schools?
Provide a succinct answer. 0.04. What is the difference between the highest and the second highest Gross enrolment ratio (%) in Tertiary schools?
Provide a short and direct response. 0.16. What is the difference between the highest and the lowest Gross enrolment ratio (%) in Pre-primary schools?
Offer a very short reply. 0.52. What is the difference between the highest and the lowest Gross enrolment ratio (%) of Primary schools?
Ensure brevity in your answer.  4.57. What is the difference between the highest and the lowest Gross enrolment ratio (%) in Secondary schools?
Your answer should be very brief. 0.99. What is the difference between the highest and the lowest Gross enrolment ratio (%) of Tertiary schools?
Offer a very short reply. 0.75. 